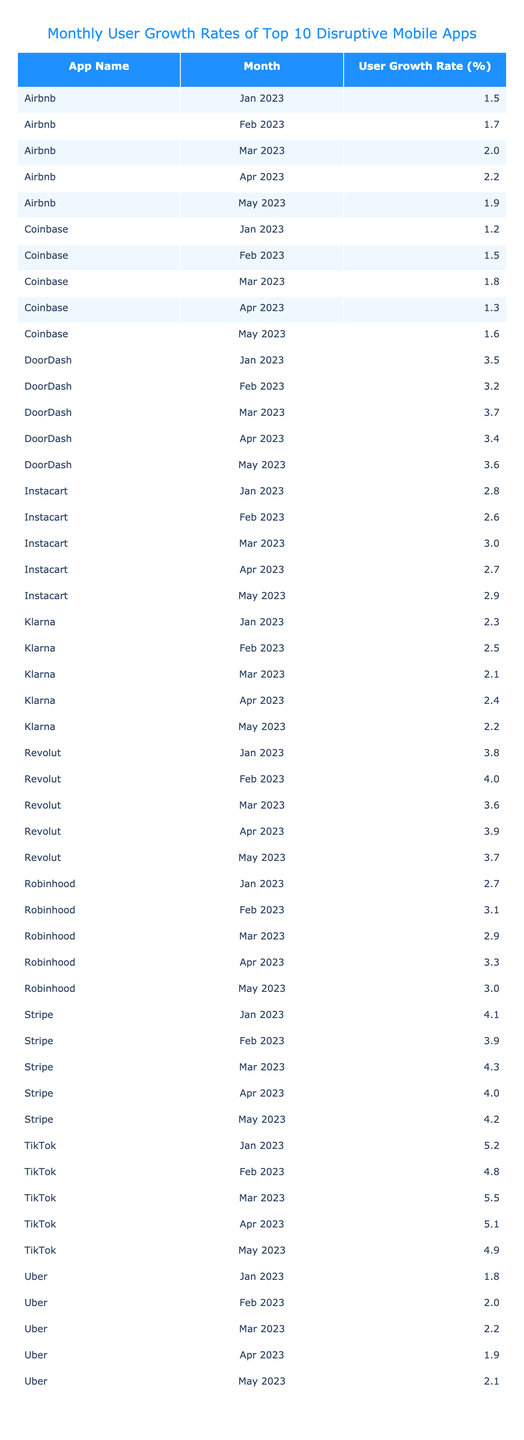What was the user growth rate for TikTok in March 2023? The table indicates that the user growth rate for TikTok in March 2023 was 5.5%.
Answer: 5.5% Which app had the highest user growth rate in May 2023? Looking at the table, TikTok had the highest user growth rate in May 2023 at 4.9%.
Answer: TikTok What is the average user growth rate for Robinhood across all five months? The user growth rates for Robinhood are 2.7, 3.1, 2.9, 3.3, and 3.0. Summing these values gives 15.0, and dividing by 5 results in an average of 3.0%.
Answer: 3.0% Which app had the lowest user growth rate in January 2023? In January 2023, the growth rates for the apps were: TikTok (5.2%), Robinhood (2.7%), Uber (1.8%), Airbnb (1.5%), DoorDash (3.5%), Coinbase (1.2%), Instacart (2.8%), Stripe (4.1%), Klarna (2.3%), and Revolut (3.8%). The lowest rate is from Coinbase at 1.2%.
Answer: Coinbase Was there any month in 2023 where Stripe's user growth rate exceeded 4%? By inspecting the table, Stripe's user growth rates were 4.1% in January, 3.9% in February, 4.3% in March, 4.0% in April, and 4.2% in May. Therefore, it did exceed 4% in January, March, April, and May.
Answer: Yes What is the difference between the maximum and minimum user growth rate for Uber during the five-month period? Uber's user growth rates are: 1.8%, 2.0%, 2.2%, 1.9%, and 2.1%. The maximum is 2.2% and the minimum is 1.8%, resulting in a difference of 2.2 - 1.8 = 0.4%.
Answer: 0.4% In which month did Airbnb achieve a user growth rate of 2.2%? According to the table, Airbnb's user growth rate was 2.2% in April 2023.
Answer: April 2023 What was the trend of user growth rates for Instacart over the five months? The rates were: 2.8%, 2.6%, 3.0%, 2.7%, and 2.9%. The trend shows an increase from January to March, then a slight decrease in April followed by a small increase in May.
Answer: Fluctuating with an increase trend then decrease Which two apps had the same user growth rate in February 2023? The table shows that Robinhood (3.1%) and Klarna (2.5%) are different, but looking closely, no two apps had the same rate in February 2023 when analyzing the data.
Answer: None What overall conclusions can be drawn about the user growth rates of the apps from January to May 2023? By examining the growth rates, it's evident that TikTok consistently maintained higher growth rates relative to others, while some apps like Uber showed lower growth rates throughout. Thus, TikTok appeared to be the most successful app in user growth, whereas Uber lagged significantly.
Answer: TikTok outperformed others; Uber had low growth rates 